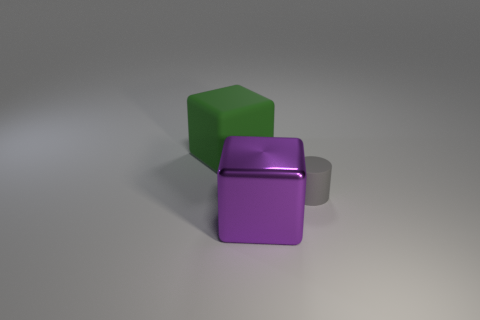How would you describe the arrangement of the blocks? The arrangement is quite simple and balanced. The three objects are placed in close proximity to each other, with the green cube resting on the top right of the purple cube, which is adjacent to the gray cylindrical object. This creates a sense of harmony and stability in the composition. 